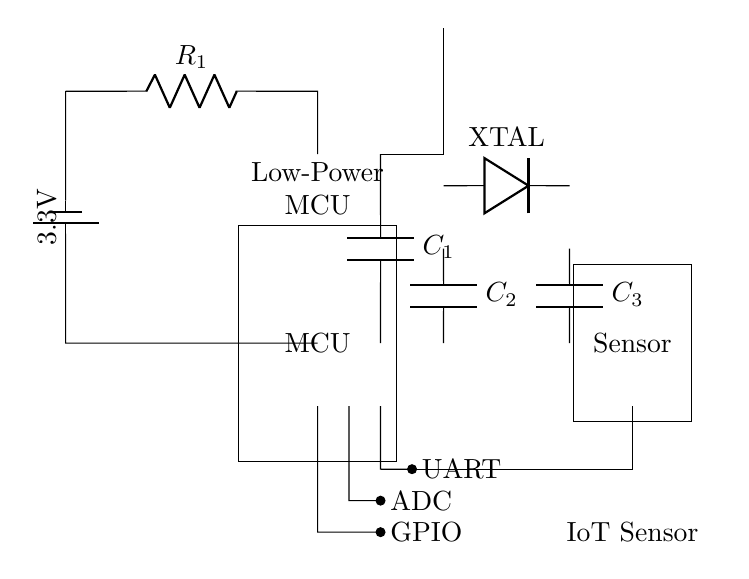What is the main component of this circuit? The main component is the MCU, which stands for microcontroller unit, located on the left side of the circuit diagram.
Answer: MCU What type of capacitor is present in the circuit? The circuit includes decoupling capacitors, specifically denoted as C1, C2, and C3, which help stabilize the power supply for the microcontroller.
Answer: Decoupling capacitors What is the purpose of the antenna in this circuit? The antenna enables wireless communication for the IoT device, allowing it to send and receive data.
Answer: Wireless communication How many sensors are connected in this circuit? The circuit shows one sensor connected, labeled as "Sensor" on the right side, indicating the presence of a single IoT sensor.
Answer: One What is the voltage source for this circuit? The voltage source is a battery, as shown by the battery symbol on the left, which provides a supply voltage labeled as 3.3V.
Answer: 3.3V How is the GPIO pin represented in the circuit? The GPIO pin is represented as a connection at the bottom of the MCU, with a line labeled GPIO leading to the right toward the sensor.
Answer: GPIO Where are the crystal oscillators located in the circuit? The crystal oscillators, indicated with the label "XTAL," are located between the microcontroller and the capacitors, providing a clock signal for the MCU.
Answer: Between the microcontroller and the capacitors 